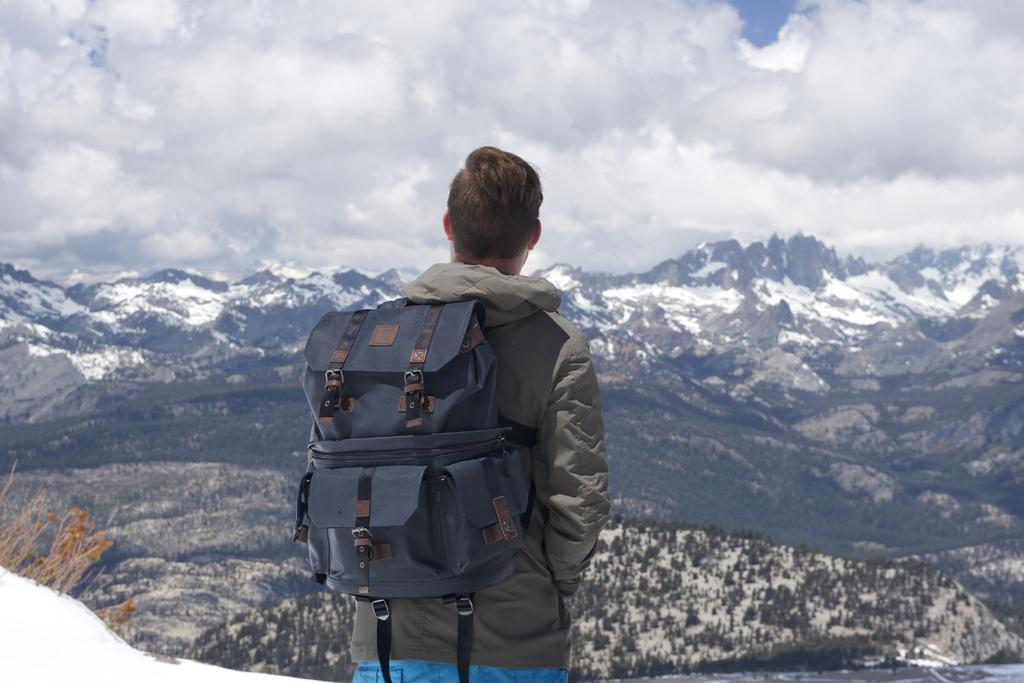Who is present in the image? There is a man in the image. What is the man doing in the image? The man is standing in the image. What is the man carrying on his back? The man is wearing a backpack in the image. What type of landscape can be seen in the image? There are mountains visible in the image. What is the weather like in the image? The sky is cloudy in the image. What sense is the man using to experience the mountains in the image? The provided facts do not mention any specific sense being used by the man to experience the mountains. 